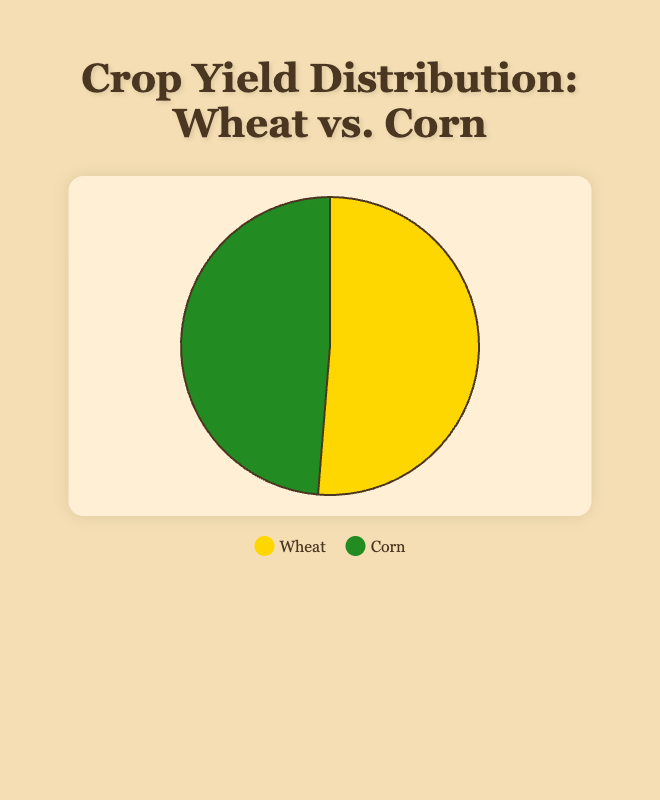Which crop has a higher total yield? Comparing the heights of the Wheat and Corn pie slices, Corn appears to be larger. Given the data, the total for Wheat is 80000 bushels, and the total for Corn is 76000 bushels. Therefore, Wheat has a higher total yield.
Answer: Wheat What is the total amount of Wheat and Corn together? By adding the total yields, we have Wheat (80000 bushels) + Corn (76000 bushels). This sums up to 156000 bushels.
Answer: 156000 bushels Which farm contributes the most to Corn yield? Analyzing the data, Golden Field Farm has the highest Corn yield at 19000 bushels.
Answer: Golden Field Farm What's the average yield of Wheat among all farms? To find the average yield, sum the Wheat yields (12000 + 18000 + 14000 + 16000 + 20000) and divide by the number of farms (5). The total is 80000; thus, the average is 80000 / 5 = 16000 bushels.
Answer: 16000 bushels Which crop forms the greater percentage of the total yield? From the pie chart's size, Wheat seems larger than Corn. Total Wheat yield is 80000 bushels and Corn is 76000 bushels. This makes Wheat roughly 51.28% and Corn 48.72% of the total (156000 bushels). Hence, Wheat forms the greater percentage.
Answer: Wheat What is the yield difference between Golden Field Farm's Wheat and Corn? Golden Field Farm's Wheat yield is 20000 bushels while the Corn yield is 19000 bushels. Subtracting these gives a difference of 1000 bushels.
Answer: 1000 bushels How much more Corn does Sunny Meadow Farm produce compared to its Wheat? Sunny Meadow Farm yields 15000 bushels of Corn and 12000 bushels of Wheat, so the difference is 15000 - 12000 = 3000 bushels.
Answer: 3000 bushels What percentage of the total yield does Mountain Ridge Farm's Wheat contribute? Mountain Ridge Farm produces 16000 bushels of Wheat. The total yield (Wheat+Corn) is 156000 bushels. Therefore, (16000 / 156000) * 100 = 10.26%.
Answer: 10.26% Which farm has the smallest Wheat yield? Comparing the data, Sunny Meadow Farm has the smallest Wheat yield at 12000 bushels.
Answer: Sunny Meadow Farm How many bushels of Corn are produced in total by Green Valley and Mountain Ridge Farms? Adding Green Valley's Corn (13000) to Mountain Ridge's Corn (12000) gives 25000 bushels.
Answer: 25000 bushels 